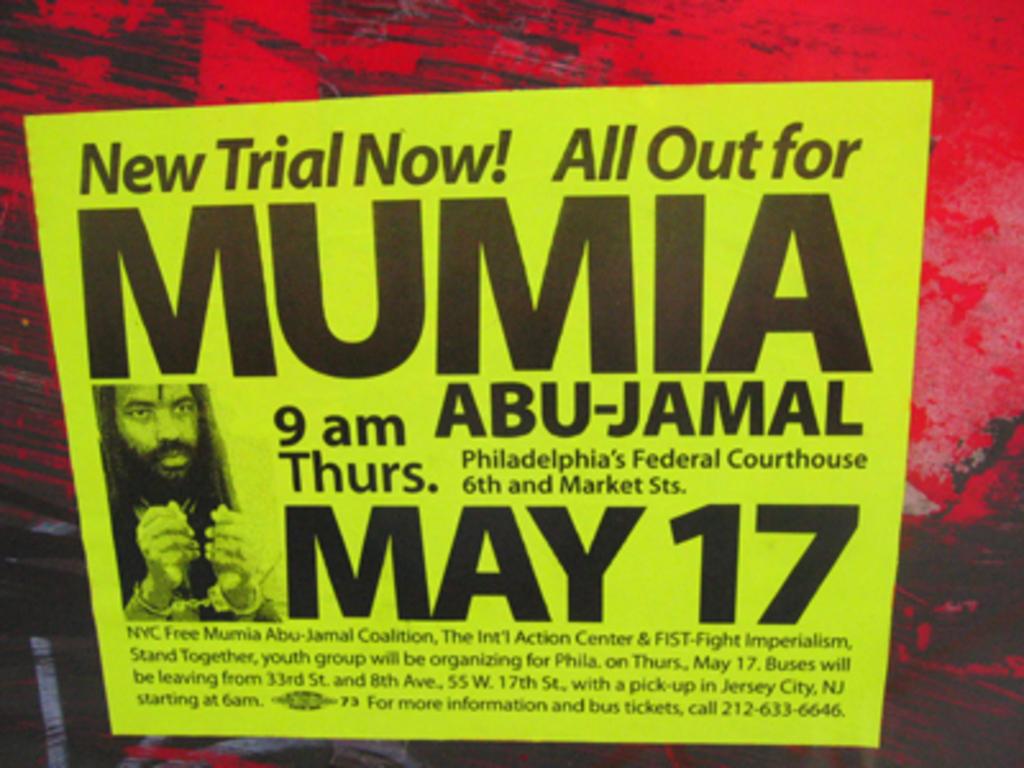What month is the event happening?
Your answer should be very brief. May. What time is the event happening?
Keep it short and to the point. 9 am. 